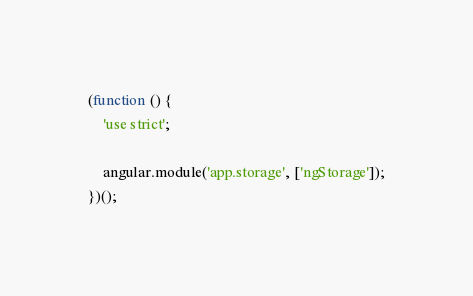Convert code to text. <code><loc_0><loc_0><loc_500><loc_500><_JavaScript_>(function () {
    'use strict';

    angular.module('app.storage', ['ngStorage']);
})();
</code> 